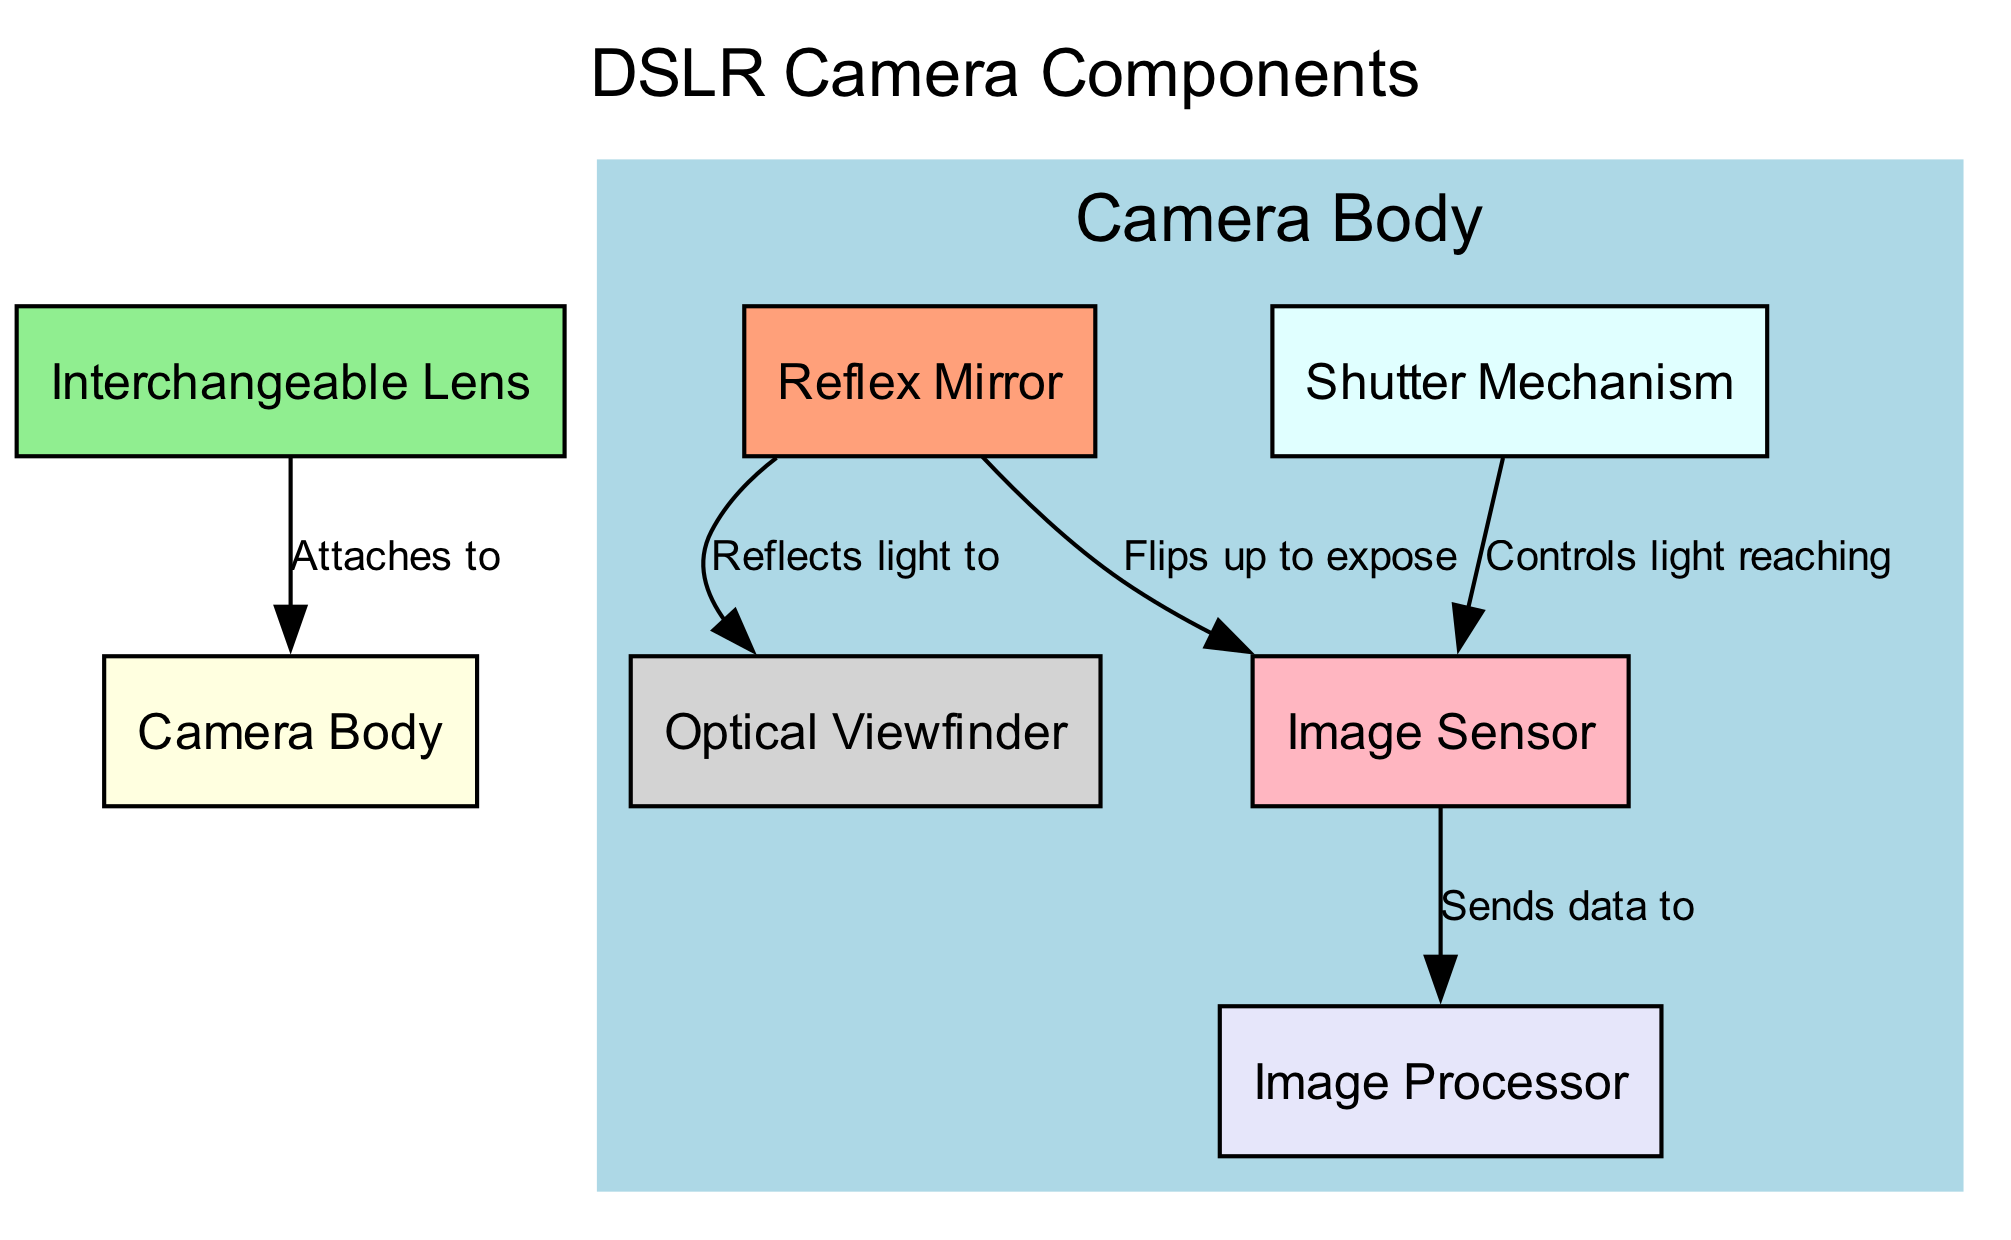What is the main component of this diagram? The diagram focuses on the internal components of a DSLR camera, with "Camera Body" as the central element around which other components relate.
Answer: Camera Body How many nodes are present in the diagram? By counting each unique node depicted in the diagram, we find a total of six: Camera Body, Interchangeable Lens, Image Sensor, Reflex Mirror, Shutter Mechanism, and Optical Viewfinder.
Answer: 6 What component attaches to the Camera Body? The diagram shows that the "Interchangeable Lens" directly connects to the "Camera Body" signifying its attachment, making this the only component designated as such.
Answer: Interchangeable Lens What controls the light reaching the Image Sensor? According to the diagram, the "Shutter Mechanism" is the component that regulates the amount of light that can pass through to the "Image Sensor."
Answer: Shutter Mechanism Which component of the camera reflects light to the Optical Viewfinder? The arrow in the diagram indicates that the "Reflex Mirror" is responsible for reflecting light towards the "Optical Viewfinder."
Answer: Reflex Mirror What does the Image Sensor send data to? The diagram illustrates that the "Image Sensor" transmits data to the "Image Processor" as its next step in the camera's operation.
Answer: Image Processor How many edges connect the various components in the diagram? Upon reviewing the diagram, there are five edges displaying the established relationships between various components, hence the count totals to five.
Answer: 5 Which component flips up to expose the Image Sensor? The diagram specifies that the "Reflex Mirror" not only reflects light but also flips up to allow light to reach the "Image Sensor," making it crucial for this function.
Answer: Reflex Mirror What color is the node representing the Image Sensor? The visual representation indicates that the node associated with the "Image Sensor" is colored light pink, distinguishing it from other components in the diagram.
Answer: Light Pink 